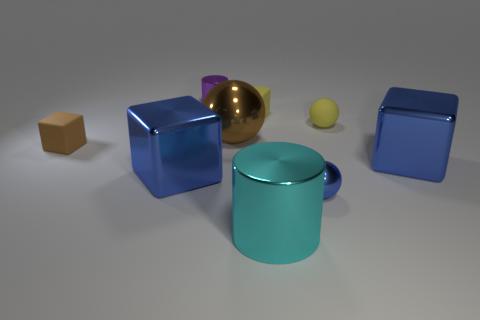Is the small yellow sphere made of the same material as the tiny yellow thing on the left side of the big cylinder? While it's challenging to determine the exact material from a visual inspection alone, the small yellow sphere shares a similar color and glossiness with the tiny yellow object on the left side of the big cylinder, suggesting that they could be made of the same or similar materials. However, factors like lighting and surface texture can affect the appearance and might lead to different interpretations. 